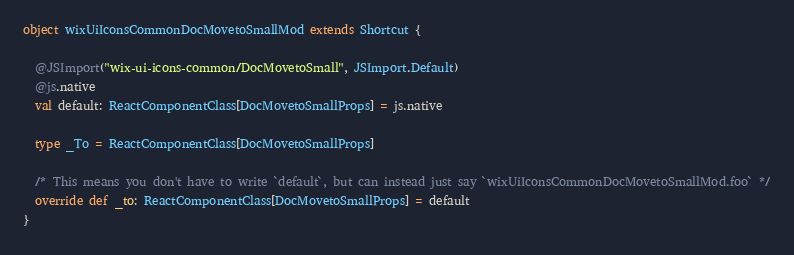Convert code to text. <code><loc_0><loc_0><loc_500><loc_500><_Scala_>
object wixUiIconsCommonDocMovetoSmallMod extends Shortcut {
  
  @JSImport("wix-ui-icons-common/DocMovetoSmall", JSImport.Default)
  @js.native
  val default: ReactComponentClass[DocMovetoSmallProps] = js.native
  
  type _To = ReactComponentClass[DocMovetoSmallProps]
  
  /* This means you don't have to write `default`, but can instead just say `wixUiIconsCommonDocMovetoSmallMod.foo` */
  override def _to: ReactComponentClass[DocMovetoSmallProps] = default
}
</code> 